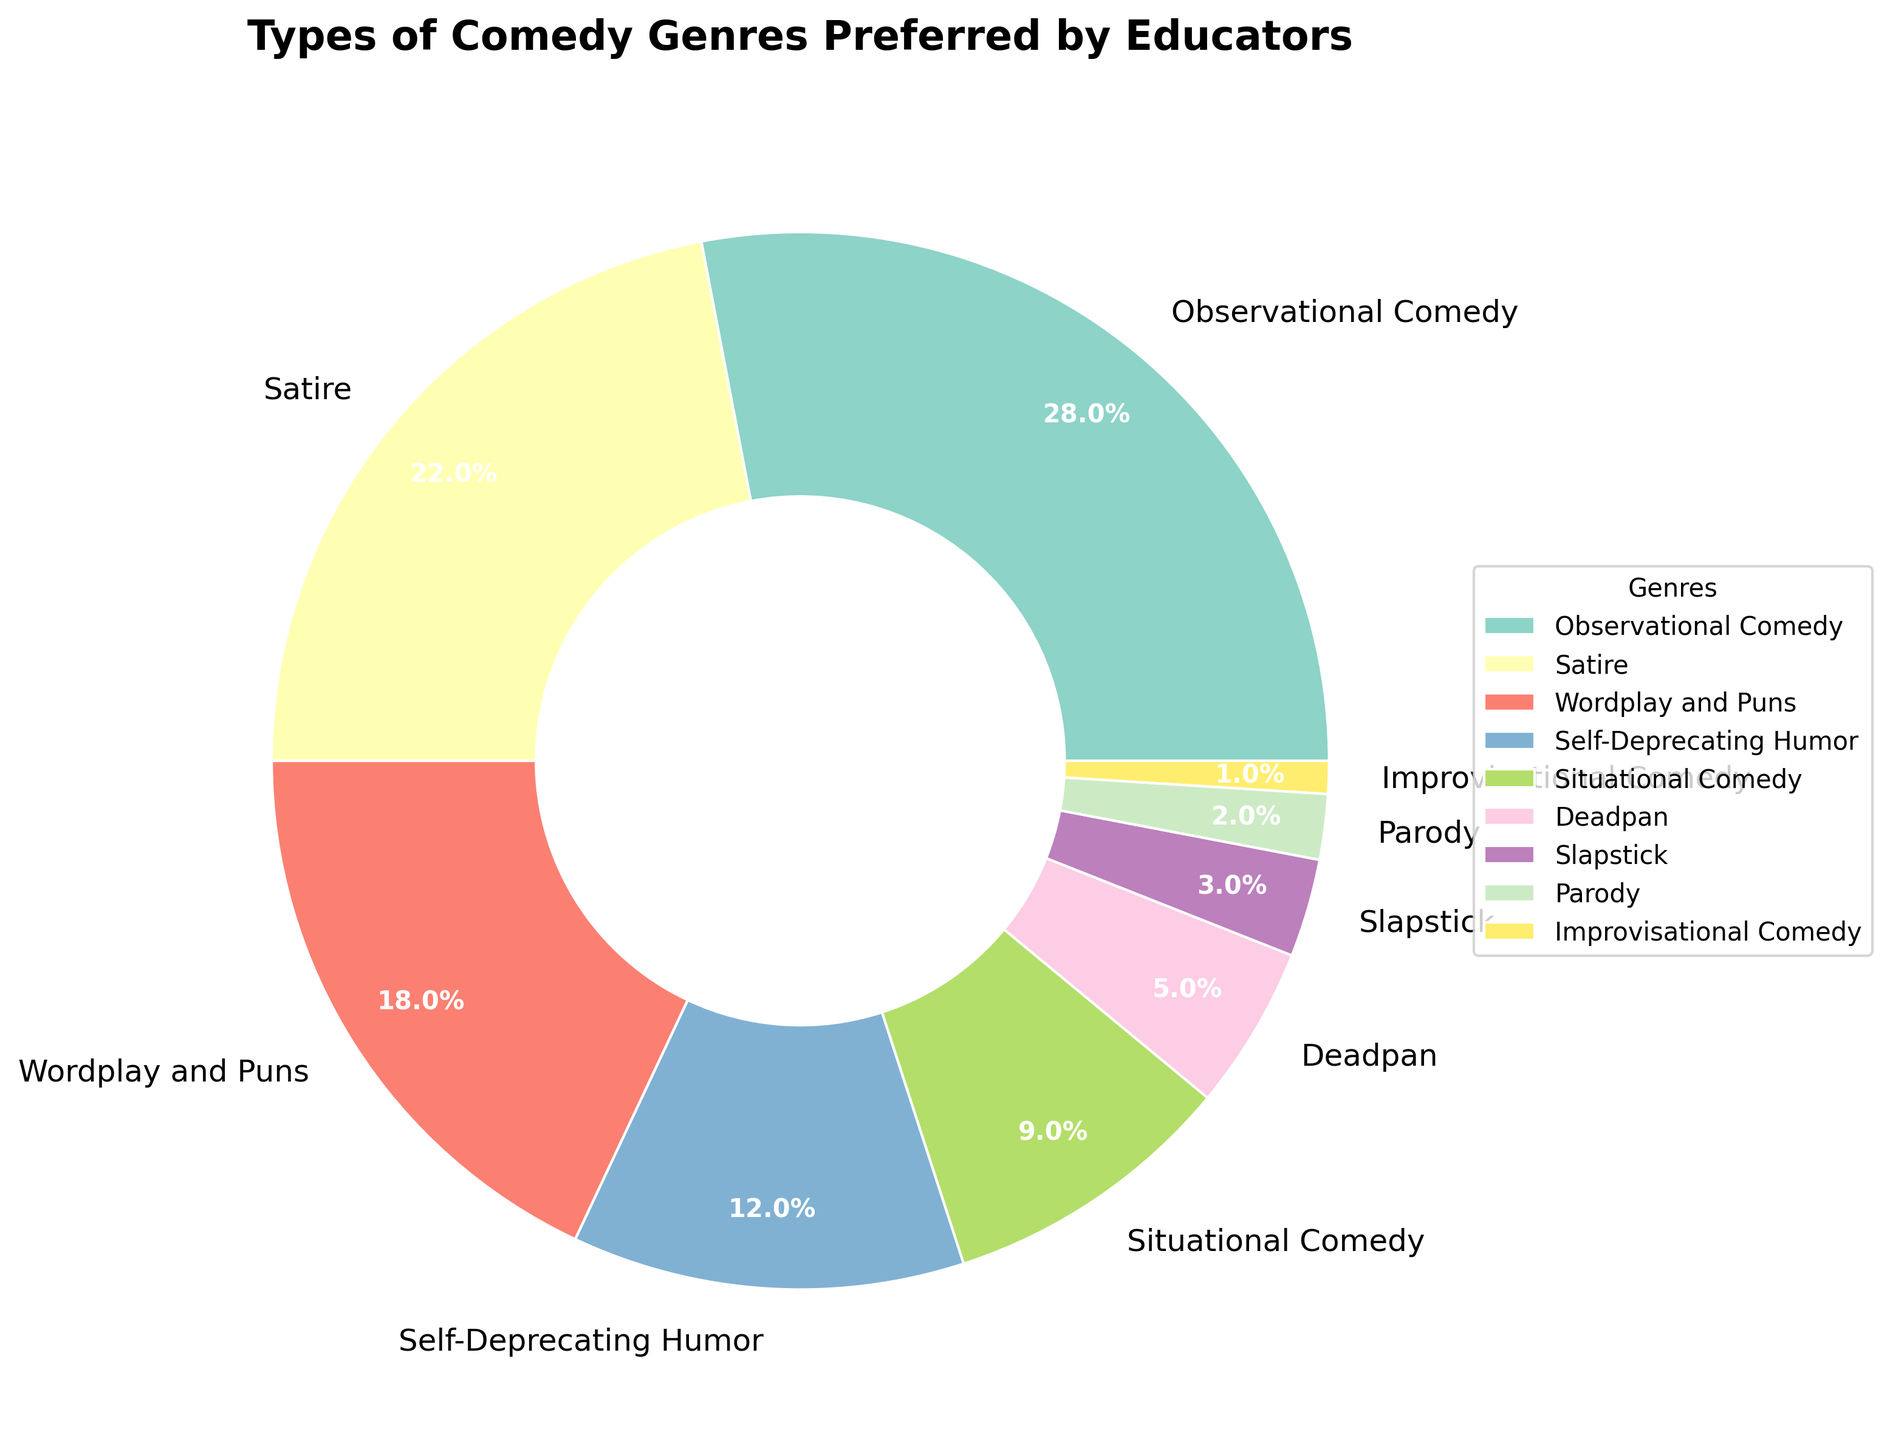Which comedy genre is the most preferred by educators? Look at the largest section of the pie chart, which is 'Observational Comedy' with 28%.
Answer: Observational Comedy Which comedy genres together make up more than 50% of the preferences? Summing the percentages of the top genres: 'Observational Comedy' (28%) + 'Satire' (22%) = 50%. Including any other genre like 'Wordplay and Puns' (18%) will make it exceed 50%.
Answer: Observational Comedy, Satire Which is more preferred, Deadpan or Slapstick? Compare the percentages: Deadpan is 5%, while Slapstick is 3%, making Deadpan more preferred.
Answer: Deadpan What is the combined percentage of 'Self-Deprecating Humor' and 'Situational Comedy'? Sum the percentages of 'Self-Deprecating Humor' (12%) and 'Situational Comedy' (9%): 12% + 9% = 21%.
Answer: 21% Which genre has the smallest percentage of preference among educators? Look at the smallest section of the pie chart, which is 'Improvisational Comedy' with 1%.
Answer: Improvisational Comedy Is 'Wordplay and Puns' more or less preferred than 'Satire'? Compare the percentages: 'Wordplay and Puns' has 18%, while 'Satire' has 22%, making Wordplay and Puns less preferred.
Answer: Less preferred What is the difference in preference between 'Situational Comedy' and 'Satire'? Subtract the percentage of 'Situational Comedy' (9%) from 'Satire' (22%): 22% - 9% = 13%.
Answer: 13% Are more educators interested in 'Slapstick' or 'Parody'? Compare the percentages: Slapstick is 3%, while Parody is 2%, making Slapstick more preferred.
Answer: Slapstick What percentage do genres other than 'Observational Comedy' contribute? Subtract the percentage of 'Observational Comedy' (28%) from the total 100%: 100% - 28% = 72%.
Answer: 72% How many genres have a preference percentage higher than 10%? Identify the genres with percentages higher than 10%: 'Observational Comedy' (28%), 'Satire' (22%), 'Wordplay and Puns' (18%), and 'Self-Deprecating Humor' (12%). There are 4 such genres.
Answer: 4 